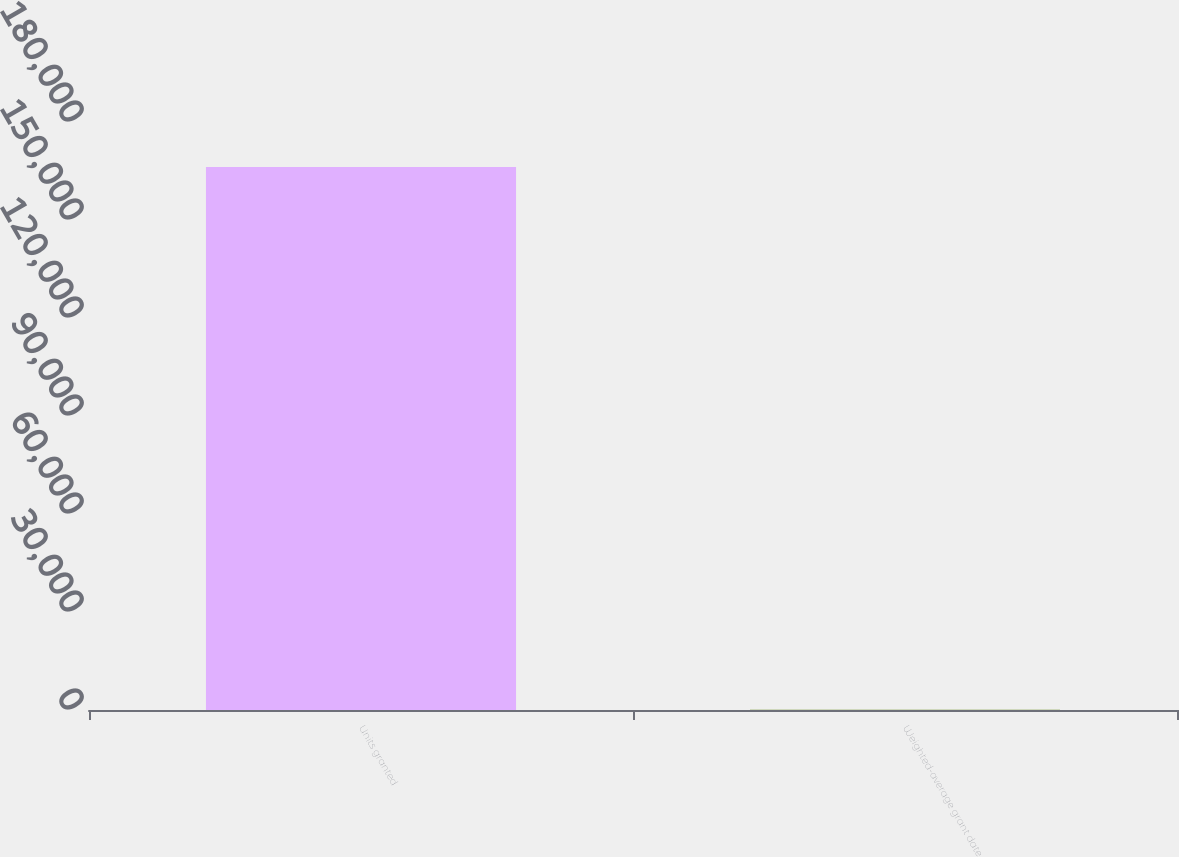Convert chart. <chart><loc_0><loc_0><loc_500><loc_500><bar_chart><fcel>Units granted<fcel>Weighted-average grant date<nl><fcel>166244<fcel>54.86<nl></chart> 